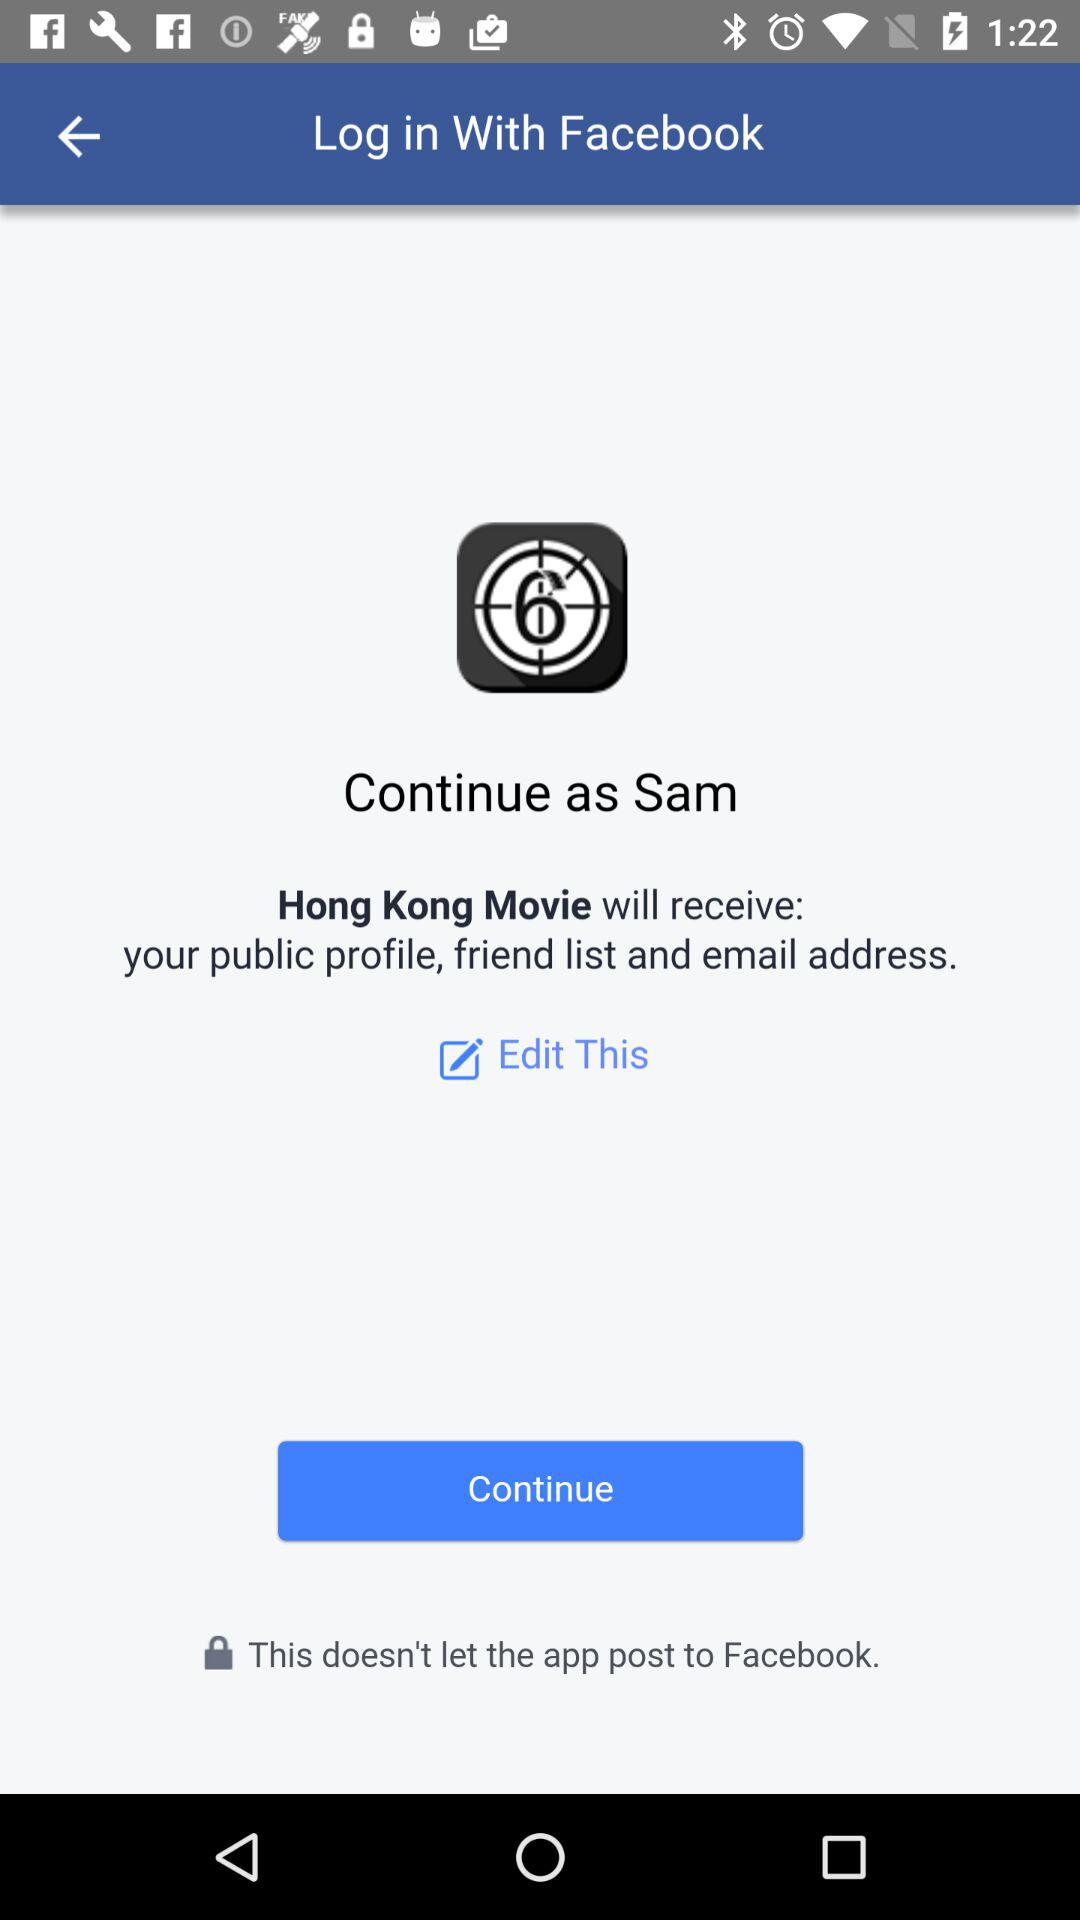What application can I use to log in? You can use "Facebook" to log in. 